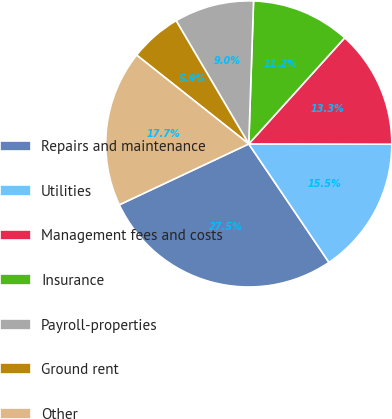<chart> <loc_0><loc_0><loc_500><loc_500><pie_chart><fcel>Repairs and maintenance<fcel>Utilities<fcel>Management fees and costs<fcel>Insurance<fcel>Payroll-properties<fcel>Ground rent<fcel>Other<nl><fcel>27.48%<fcel>15.5%<fcel>13.33%<fcel>11.17%<fcel>9.01%<fcel>5.86%<fcel>17.66%<nl></chart> 